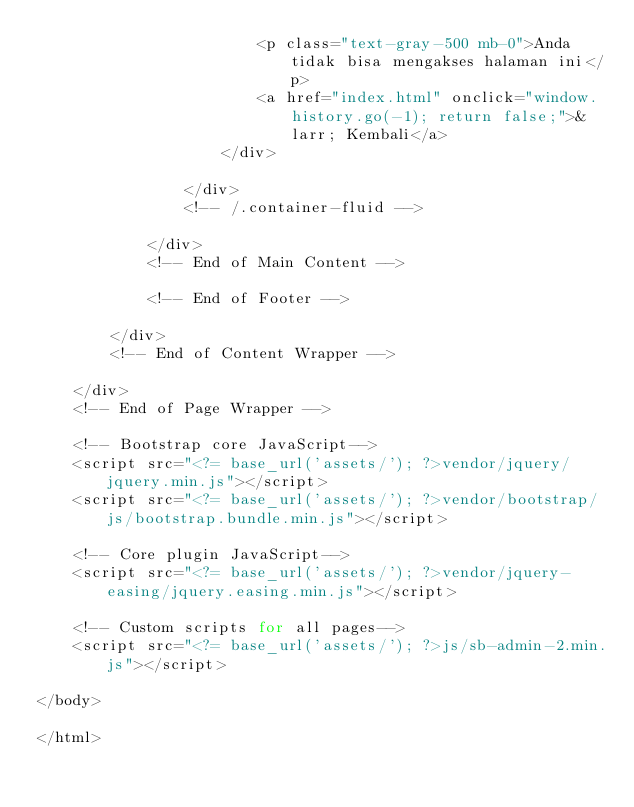Convert code to text. <code><loc_0><loc_0><loc_500><loc_500><_PHP_>                        <p class="text-gray-500 mb-0">Anda tidak bisa mengakses halaman ini</p>
                        <a href="index.html" onclick="window.history.go(-1); return false;">&larr; Kembali</a>
                    </div>

                </div>
                <!-- /.container-fluid -->

            </div>
            <!-- End of Main Content -->

            <!-- End of Footer -->

        </div>
        <!-- End of Content Wrapper -->

    </div>
    <!-- End of Page Wrapper -->

    <!-- Bootstrap core JavaScript-->
    <script src="<?= base_url('assets/'); ?>vendor/jquery/jquery.min.js"></script>
    <script src="<?= base_url('assets/'); ?>vendor/bootstrap/js/bootstrap.bundle.min.js"></script>

    <!-- Core plugin JavaScript-->
    <script src="<?= base_url('assets/'); ?>vendor/jquery-easing/jquery.easing.min.js"></script>

    <!-- Custom scripts for all pages-->
    <script src="<?= base_url('assets/'); ?>js/sb-admin-2.min.js"></script>

</body>

</html></code> 